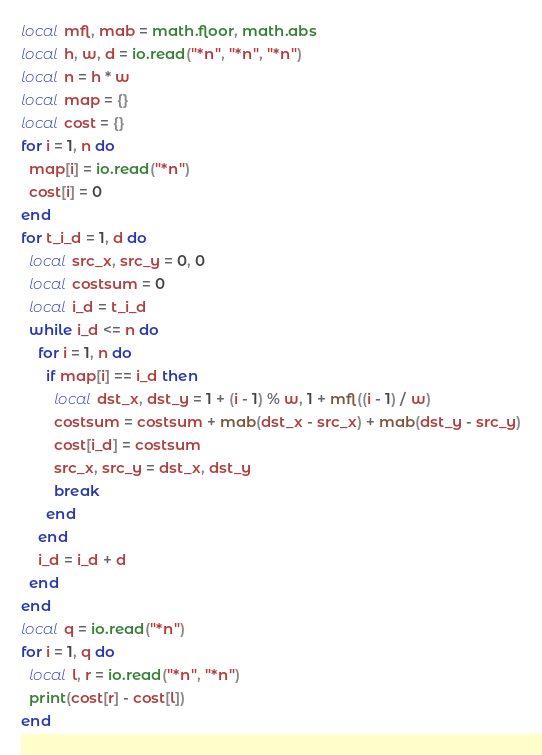<code> <loc_0><loc_0><loc_500><loc_500><_Lua_>local mfl, mab = math.floor, math.abs
local h, w, d = io.read("*n", "*n", "*n")
local n = h * w
local map = {}
local cost = {}
for i = 1, n do
  map[i] = io.read("*n")
  cost[i] = 0
end
for t_i_d = 1, d do
  local src_x, src_y = 0, 0
  local costsum = 0
  local i_d = t_i_d
  while i_d <= n do
    for i = 1, n do
      if map[i] == i_d then
        local dst_x, dst_y = 1 + (i - 1) % w, 1 + mfl((i - 1) / w)
        costsum = costsum + mab(dst_x - src_x) + mab(dst_y - src_y)
        cost[i_d] = costsum
        src_x, src_y = dst_x, dst_y
        break
      end
    end
    i_d = i_d + d
  end
end
local q = io.read("*n")
for i = 1, q do
  local l, r = io.read("*n", "*n")
  print(cost[r] - cost[l])
end
</code> 